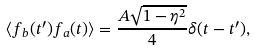Convert formula to latex. <formula><loc_0><loc_0><loc_500><loc_500>\langle f _ { b } ( t ^ { \prime } ) f _ { a } ( t ) \rangle = \frac { A \sqrt { 1 - \eta ^ { 2 } } } { 4 } \delta ( t - t ^ { \prime } ) ,</formula> 